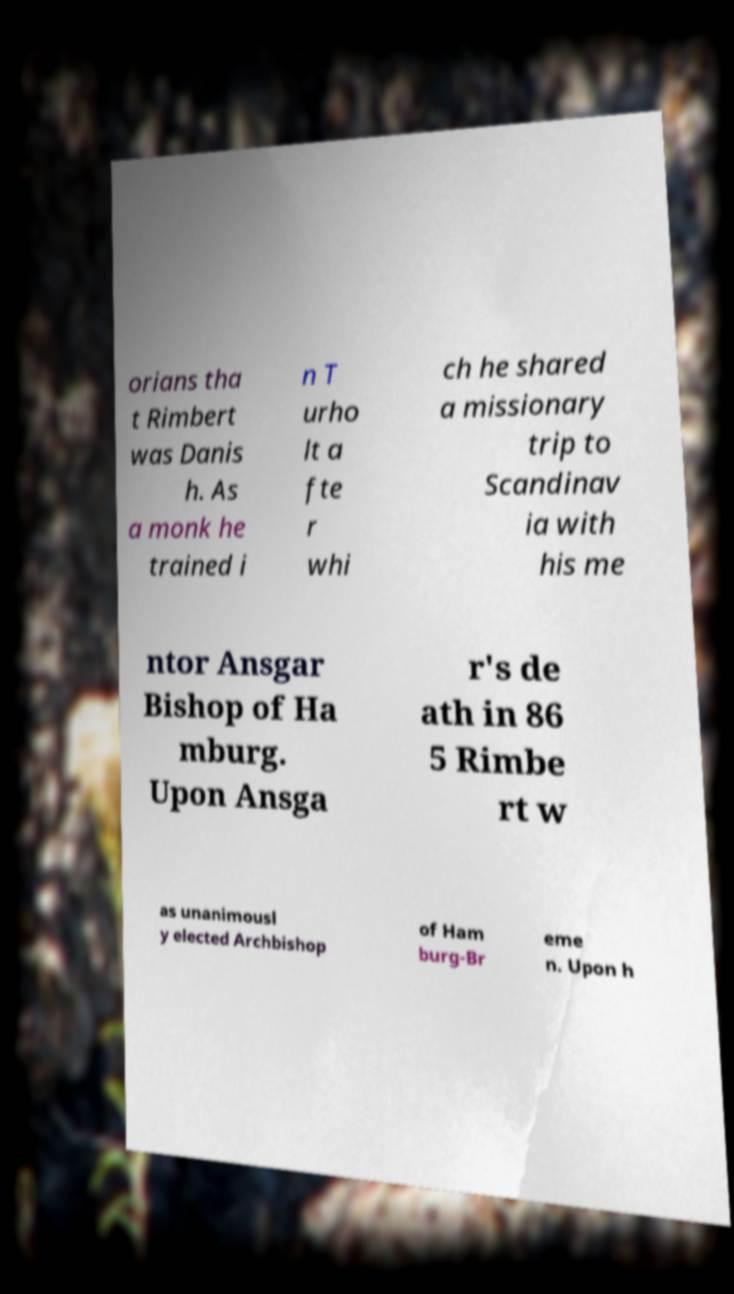I need the written content from this picture converted into text. Can you do that? orians tha t Rimbert was Danis h. As a monk he trained i n T urho lt a fte r whi ch he shared a missionary trip to Scandinav ia with his me ntor Ansgar Bishop of Ha mburg. Upon Ansga r's de ath in 86 5 Rimbe rt w as unanimousl y elected Archbishop of Ham burg-Br eme n. Upon h 